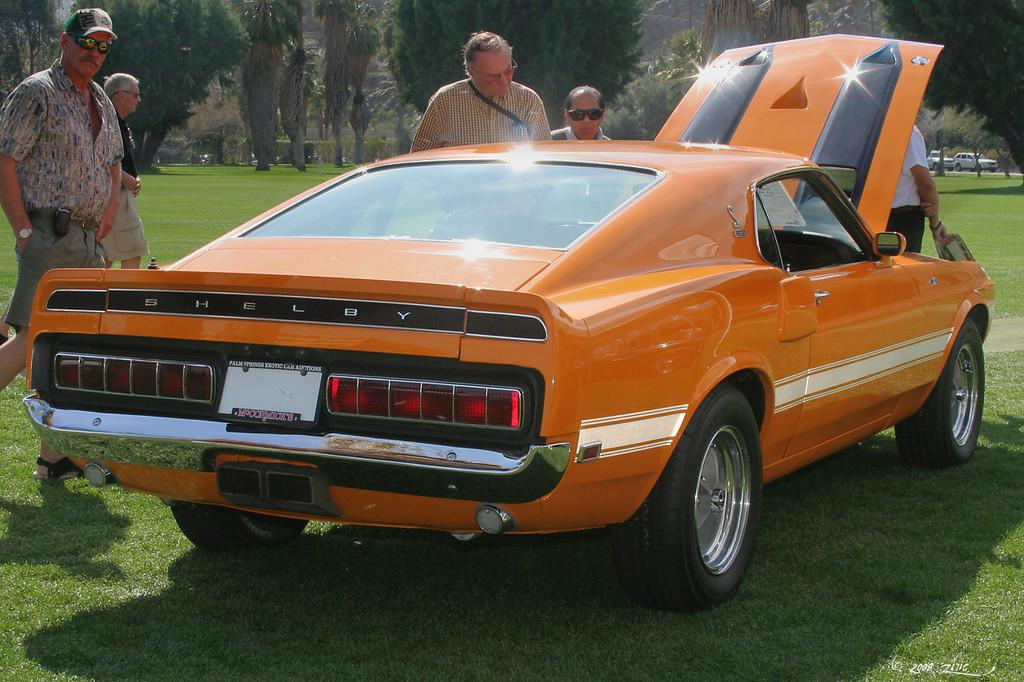Where is the car located in the image? The car is parked on the grass in the image. What can be seen in front of the car? There are people standing in front of the car. What is visible in the background of the image? There are trees in the background of the image. What type of pancake is being served to the people standing in front of the car? There is no pancake present in the image; it only features a car parked on the grass with people standing in front of it. 